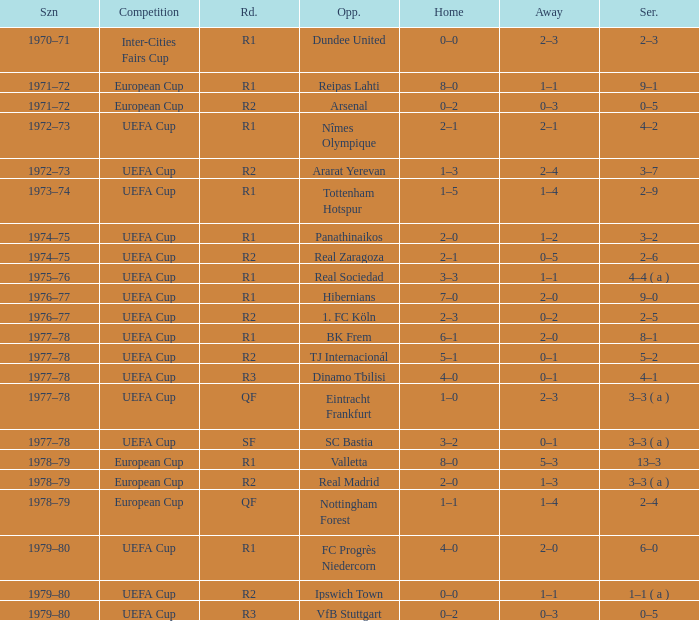Which Home has a Round of r1, and an Opponent of dundee united? 0–0. 